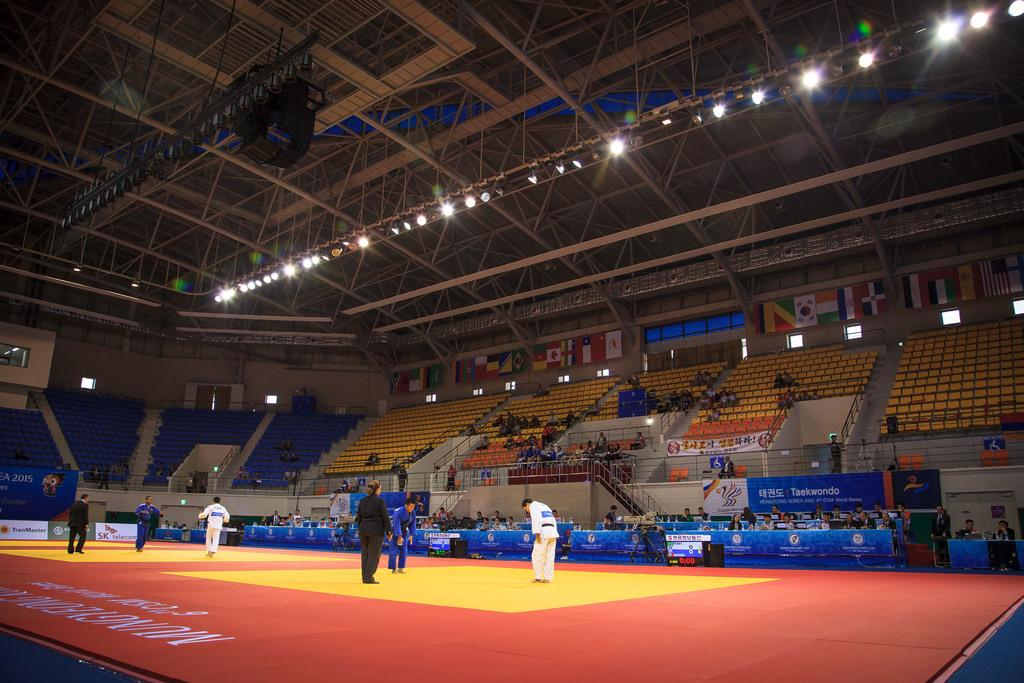<image>
Create a compact narrative representing the image presented. A martial arts contest with one Korean participant and another from Iran, two matches are being held in an almost empty venue. 